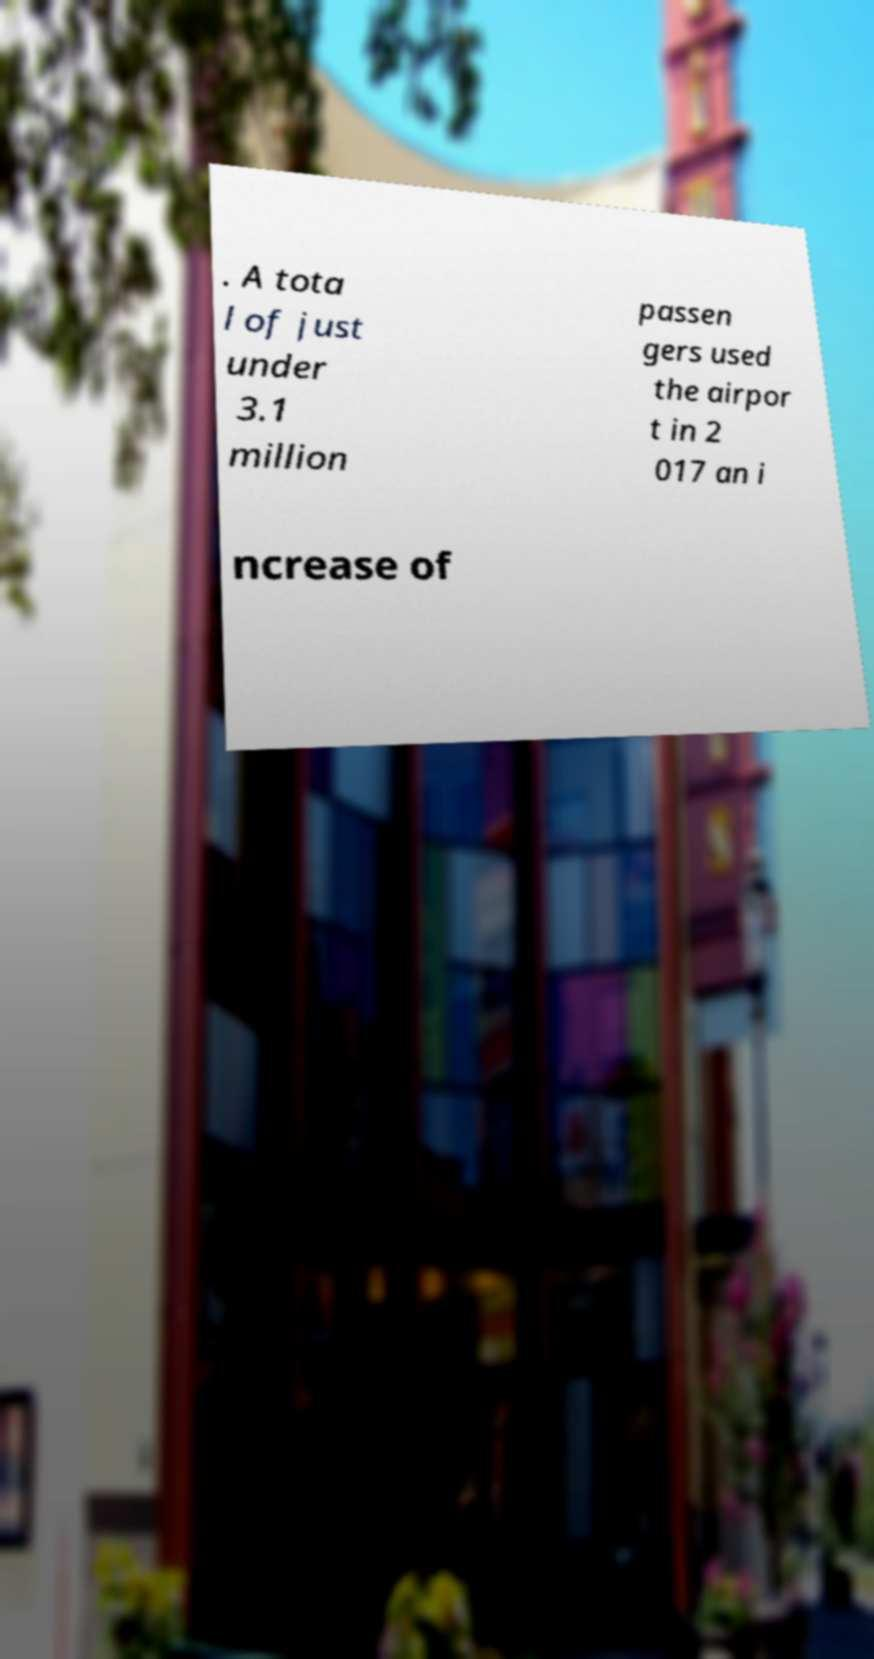For documentation purposes, I need the text within this image transcribed. Could you provide that? . A tota l of just under 3.1 million passen gers used the airpor t in 2 017 an i ncrease of 